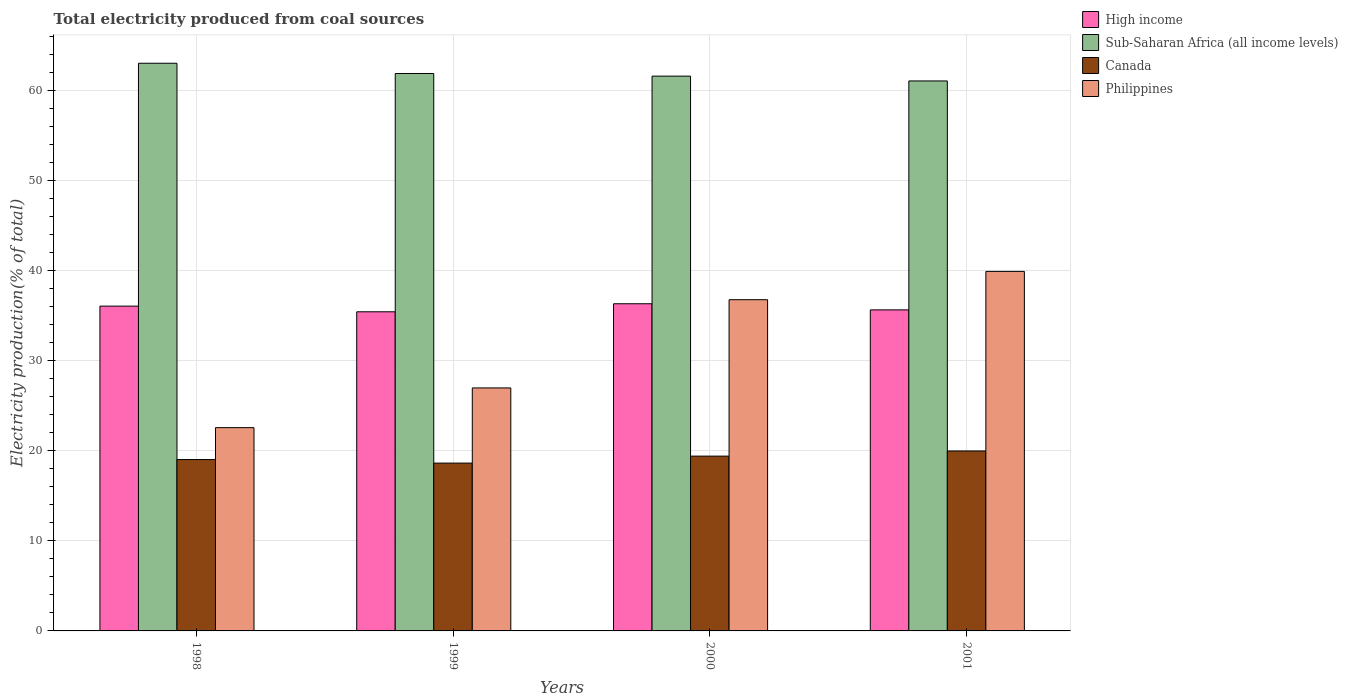How many different coloured bars are there?
Ensure brevity in your answer.  4. How many groups of bars are there?
Provide a short and direct response. 4. What is the total electricity produced in Canada in 2000?
Ensure brevity in your answer.  19.42. Across all years, what is the maximum total electricity produced in Canada?
Ensure brevity in your answer.  19.99. Across all years, what is the minimum total electricity produced in Sub-Saharan Africa (all income levels)?
Offer a very short reply. 61.09. In which year was the total electricity produced in Canada maximum?
Your response must be concise. 2001. What is the total total electricity produced in Sub-Saharan Africa (all income levels) in the graph?
Offer a very short reply. 247.68. What is the difference between the total electricity produced in High income in 2000 and that in 2001?
Make the answer very short. 0.68. What is the difference between the total electricity produced in Canada in 2000 and the total electricity produced in High income in 1999?
Ensure brevity in your answer.  -16.03. What is the average total electricity produced in Sub-Saharan Africa (all income levels) per year?
Give a very brief answer. 61.92. In the year 2000, what is the difference between the total electricity produced in High income and total electricity produced in Philippines?
Give a very brief answer. -0.45. In how many years, is the total electricity produced in Philippines greater than 46 %?
Make the answer very short. 0. What is the ratio of the total electricity produced in Philippines in 1998 to that in 2000?
Offer a terse response. 0.61. What is the difference between the highest and the second highest total electricity produced in Philippines?
Your answer should be very brief. 3.14. What is the difference between the highest and the lowest total electricity produced in High income?
Your response must be concise. 0.89. Is it the case that in every year, the sum of the total electricity produced in High income and total electricity produced in Philippines is greater than the sum of total electricity produced in Canada and total electricity produced in Sub-Saharan Africa (all income levels)?
Keep it short and to the point. Yes. What does the 1st bar from the left in 2000 represents?
Provide a succinct answer. High income. What does the 3rd bar from the right in 2000 represents?
Ensure brevity in your answer.  Sub-Saharan Africa (all income levels). Is it the case that in every year, the sum of the total electricity produced in Philippines and total electricity produced in Canada is greater than the total electricity produced in High income?
Ensure brevity in your answer.  Yes. How many bars are there?
Provide a short and direct response. 16. What is the difference between two consecutive major ticks on the Y-axis?
Offer a very short reply. 10. Does the graph contain any zero values?
Ensure brevity in your answer.  No. Where does the legend appear in the graph?
Your response must be concise. Top right. How many legend labels are there?
Provide a short and direct response. 4. What is the title of the graph?
Your response must be concise. Total electricity produced from coal sources. What is the label or title of the X-axis?
Your response must be concise. Years. What is the label or title of the Y-axis?
Keep it short and to the point. Electricity production(% of total). What is the Electricity production(% of total) in High income in 1998?
Offer a very short reply. 36.08. What is the Electricity production(% of total) of Sub-Saharan Africa (all income levels) in 1998?
Your answer should be very brief. 63.05. What is the Electricity production(% of total) in Canada in 1998?
Offer a very short reply. 19.03. What is the Electricity production(% of total) of Philippines in 1998?
Your answer should be very brief. 22.58. What is the Electricity production(% of total) of High income in 1999?
Provide a succinct answer. 35.45. What is the Electricity production(% of total) in Sub-Saharan Africa (all income levels) in 1999?
Make the answer very short. 61.91. What is the Electricity production(% of total) in Canada in 1999?
Keep it short and to the point. 18.64. What is the Electricity production(% of total) of Philippines in 1999?
Ensure brevity in your answer.  26.99. What is the Electricity production(% of total) of High income in 2000?
Make the answer very short. 36.34. What is the Electricity production(% of total) of Sub-Saharan Africa (all income levels) in 2000?
Your answer should be compact. 61.62. What is the Electricity production(% of total) in Canada in 2000?
Give a very brief answer. 19.42. What is the Electricity production(% of total) of Philippines in 2000?
Ensure brevity in your answer.  36.79. What is the Electricity production(% of total) in High income in 2001?
Your answer should be compact. 35.66. What is the Electricity production(% of total) in Sub-Saharan Africa (all income levels) in 2001?
Provide a succinct answer. 61.09. What is the Electricity production(% of total) in Canada in 2001?
Your answer should be very brief. 19.99. What is the Electricity production(% of total) in Philippines in 2001?
Keep it short and to the point. 39.93. Across all years, what is the maximum Electricity production(% of total) in High income?
Provide a short and direct response. 36.34. Across all years, what is the maximum Electricity production(% of total) in Sub-Saharan Africa (all income levels)?
Offer a terse response. 63.05. Across all years, what is the maximum Electricity production(% of total) of Canada?
Your answer should be compact. 19.99. Across all years, what is the maximum Electricity production(% of total) in Philippines?
Keep it short and to the point. 39.93. Across all years, what is the minimum Electricity production(% of total) of High income?
Offer a terse response. 35.45. Across all years, what is the minimum Electricity production(% of total) of Sub-Saharan Africa (all income levels)?
Provide a short and direct response. 61.09. Across all years, what is the minimum Electricity production(% of total) of Canada?
Give a very brief answer. 18.64. Across all years, what is the minimum Electricity production(% of total) of Philippines?
Your response must be concise. 22.58. What is the total Electricity production(% of total) in High income in the graph?
Make the answer very short. 143.52. What is the total Electricity production(% of total) in Sub-Saharan Africa (all income levels) in the graph?
Give a very brief answer. 247.68. What is the total Electricity production(% of total) in Canada in the graph?
Provide a succinct answer. 77.08. What is the total Electricity production(% of total) of Philippines in the graph?
Provide a short and direct response. 126.3. What is the difference between the Electricity production(% of total) in High income in 1998 and that in 1999?
Your response must be concise. 0.63. What is the difference between the Electricity production(% of total) of Sub-Saharan Africa (all income levels) in 1998 and that in 1999?
Give a very brief answer. 1.14. What is the difference between the Electricity production(% of total) in Canada in 1998 and that in 1999?
Offer a very short reply. 0.39. What is the difference between the Electricity production(% of total) in Philippines in 1998 and that in 1999?
Ensure brevity in your answer.  -4.41. What is the difference between the Electricity production(% of total) in High income in 1998 and that in 2000?
Provide a succinct answer. -0.26. What is the difference between the Electricity production(% of total) of Sub-Saharan Africa (all income levels) in 1998 and that in 2000?
Offer a terse response. 1.43. What is the difference between the Electricity production(% of total) in Canada in 1998 and that in 2000?
Your response must be concise. -0.38. What is the difference between the Electricity production(% of total) of Philippines in 1998 and that in 2000?
Your response must be concise. -14.21. What is the difference between the Electricity production(% of total) in High income in 1998 and that in 2001?
Provide a short and direct response. 0.42. What is the difference between the Electricity production(% of total) in Sub-Saharan Africa (all income levels) in 1998 and that in 2001?
Your answer should be very brief. 1.96. What is the difference between the Electricity production(% of total) in Canada in 1998 and that in 2001?
Offer a terse response. -0.95. What is the difference between the Electricity production(% of total) in Philippines in 1998 and that in 2001?
Your answer should be compact. -17.35. What is the difference between the Electricity production(% of total) in High income in 1999 and that in 2000?
Your answer should be compact. -0.89. What is the difference between the Electricity production(% of total) of Sub-Saharan Africa (all income levels) in 1999 and that in 2000?
Provide a succinct answer. 0.29. What is the difference between the Electricity production(% of total) of Canada in 1999 and that in 2000?
Your answer should be very brief. -0.78. What is the difference between the Electricity production(% of total) in Philippines in 1999 and that in 2000?
Ensure brevity in your answer.  -9.8. What is the difference between the Electricity production(% of total) in High income in 1999 and that in 2001?
Provide a short and direct response. -0.21. What is the difference between the Electricity production(% of total) of Sub-Saharan Africa (all income levels) in 1999 and that in 2001?
Ensure brevity in your answer.  0.82. What is the difference between the Electricity production(% of total) in Canada in 1999 and that in 2001?
Provide a short and direct response. -1.35. What is the difference between the Electricity production(% of total) of Philippines in 1999 and that in 2001?
Your response must be concise. -12.94. What is the difference between the Electricity production(% of total) in High income in 2000 and that in 2001?
Ensure brevity in your answer.  0.68. What is the difference between the Electricity production(% of total) of Sub-Saharan Africa (all income levels) in 2000 and that in 2001?
Your response must be concise. 0.53. What is the difference between the Electricity production(% of total) in Canada in 2000 and that in 2001?
Ensure brevity in your answer.  -0.57. What is the difference between the Electricity production(% of total) in Philippines in 2000 and that in 2001?
Provide a succinct answer. -3.14. What is the difference between the Electricity production(% of total) of High income in 1998 and the Electricity production(% of total) of Sub-Saharan Africa (all income levels) in 1999?
Your response must be concise. -25.84. What is the difference between the Electricity production(% of total) of High income in 1998 and the Electricity production(% of total) of Canada in 1999?
Provide a succinct answer. 17.44. What is the difference between the Electricity production(% of total) in High income in 1998 and the Electricity production(% of total) in Philippines in 1999?
Offer a very short reply. 9.09. What is the difference between the Electricity production(% of total) in Sub-Saharan Africa (all income levels) in 1998 and the Electricity production(% of total) in Canada in 1999?
Offer a terse response. 44.41. What is the difference between the Electricity production(% of total) of Sub-Saharan Africa (all income levels) in 1998 and the Electricity production(% of total) of Philippines in 1999?
Offer a terse response. 36.06. What is the difference between the Electricity production(% of total) of Canada in 1998 and the Electricity production(% of total) of Philippines in 1999?
Your answer should be compact. -7.96. What is the difference between the Electricity production(% of total) of High income in 1998 and the Electricity production(% of total) of Sub-Saharan Africa (all income levels) in 2000?
Your answer should be compact. -25.55. What is the difference between the Electricity production(% of total) in High income in 1998 and the Electricity production(% of total) in Canada in 2000?
Give a very brief answer. 16.66. What is the difference between the Electricity production(% of total) of High income in 1998 and the Electricity production(% of total) of Philippines in 2000?
Offer a very short reply. -0.71. What is the difference between the Electricity production(% of total) of Sub-Saharan Africa (all income levels) in 1998 and the Electricity production(% of total) of Canada in 2000?
Give a very brief answer. 43.64. What is the difference between the Electricity production(% of total) in Sub-Saharan Africa (all income levels) in 1998 and the Electricity production(% of total) in Philippines in 2000?
Give a very brief answer. 26.26. What is the difference between the Electricity production(% of total) in Canada in 1998 and the Electricity production(% of total) in Philippines in 2000?
Your answer should be compact. -17.76. What is the difference between the Electricity production(% of total) in High income in 1998 and the Electricity production(% of total) in Sub-Saharan Africa (all income levels) in 2001?
Keep it short and to the point. -25.01. What is the difference between the Electricity production(% of total) in High income in 1998 and the Electricity production(% of total) in Canada in 2001?
Make the answer very short. 16.09. What is the difference between the Electricity production(% of total) in High income in 1998 and the Electricity production(% of total) in Philippines in 2001?
Offer a very short reply. -3.86. What is the difference between the Electricity production(% of total) of Sub-Saharan Africa (all income levels) in 1998 and the Electricity production(% of total) of Canada in 2001?
Your answer should be compact. 43.06. What is the difference between the Electricity production(% of total) of Sub-Saharan Africa (all income levels) in 1998 and the Electricity production(% of total) of Philippines in 2001?
Your answer should be very brief. 23.12. What is the difference between the Electricity production(% of total) of Canada in 1998 and the Electricity production(% of total) of Philippines in 2001?
Keep it short and to the point. -20.9. What is the difference between the Electricity production(% of total) in High income in 1999 and the Electricity production(% of total) in Sub-Saharan Africa (all income levels) in 2000?
Make the answer very short. -26.18. What is the difference between the Electricity production(% of total) in High income in 1999 and the Electricity production(% of total) in Canada in 2000?
Make the answer very short. 16.03. What is the difference between the Electricity production(% of total) in High income in 1999 and the Electricity production(% of total) in Philippines in 2000?
Offer a terse response. -1.34. What is the difference between the Electricity production(% of total) of Sub-Saharan Africa (all income levels) in 1999 and the Electricity production(% of total) of Canada in 2000?
Make the answer very short. 42.5. What is the difference between the Electricity production(% of total) of Sub-Saharan Africa (all income levels) in 1999 and the Electricity production(% of total) of Philippines in 2000?
Give a very brief answer. 25.12. What is the difference between the Electricity production(% of total) in Canada in 1999 and the Electricity production(% of total) in Philippines in 2000?
Provide a succinct answer. -18.15. What is the difference between the Electricity production(% of total) in High income in 1999 and the Electricity production(% of total) in Sub-Saharan Africa (all income levels) in 2001?
Provide a short and direct response. -25.64. What is the difference between the Electricity production(% of total) in High income in 1999 and the Electricity production(% of total) in Canada in 2001?
Provide a short and direct response. 15.46. What is the difference between the Electricity production(% of total) of High income in 1999 and the Electricity production(% of total) of Philippines in 2001?
Make the answer very short. -4.49. What is the difference between the Electricity production(% of total) in Sub-Saharan Africa (all income levels) in 1999 and the Electricity production(% of total) in Canada in 2001?
Give a very brief answer. 41.92. What is the difference between the Electricity production(% of total) of Sub-Saharan Africa (all income levels) in 1999 and the Electricity production(% of total) of Philippines in 2001?
Your answer should be very brief. 21.98. What is the difference between the Electricity production(% of total) of Canada in 1999 and the Electricity production(% of total) of Philippines in 2001?
Your response must be concise. -21.29. What is the difference between the Electricity production(% of total) in High income in 2000 and the Electricity production(% of total) in Sub-Saharan Africa (all income levels) in 2001?
Make the answer very short. -24.75. What is the difference between the Electricity production(% of total) of High income in 2000 and the Electricity production(% of total) of Canada in 2001?
Your answer should be very brief. 16.35. What is the difference between the Electricity production(% of total) in High income in 2000 and the Electricity production(% of total) in Philippines in 2001?
Your response must be concise. -3.59. What is the difference between the Electricity production(% of total) of Sub-Saharan Africa (all income levels) in 2000 and the Electricity production(% of total) of Canada in 2001?
Your answer should be very brief. 41.63. What is the difference between the Electricity production(% of total) of Sub-Saharan Africa (all income levels) in 2000 and the Electricity production(% of total) of Philippines in 2001?
Keep it short and to the point. 21.69. What is the difference between the Electricity production(% of total) of Canada in 2000 and the Electricity production(% of total) of Philippines in 2001?
Your response must be concise. -20.52. What is the average Electricity production(% of total) in High income per year?
Offer a terse response. 35.88. What is the average Electricity production(% of total) of Sub-Saharan Africa (all income levels) per year?
Ensure brevity in your answer.  61.92. What is the average Electricity production(% of total) of Canada per year?
Make the answer very short. 19.27. What is the average Electricity production(% of total) in Philippines per year?
Make the answer very short. 31.57. In the year 1998, what is the difference between the Electricity production(% of total) of High income and Electricity production(% of total) of Sub-Saharan Africa (all income levels)?
Offer a terse response. -26.98. In the year 1998, what is the difference between the Electricity production(% of total) of High income and Electricity production(% of total) of Canada?
Provide a short and direct response. 17.04. In the year 1998, what is the difference between the Electricity production(% of total) in High income and Electricity production(% of total) in Philippines?
Your answer should be very brief. 13.5. In the year 1998, what is the difference between the Electricity production(% of total) in Sub-Saharan Africa (all income levels) and Electricity production(% of total) in Canada?
Your response must be concise. 44.02. In the year 1998, what is the difference between the Electricity production(% of total) in Sub-Saharan Africa (all income levels) and Electricity production(% of total) in Philippines?
Your answer should be very brief. 40.47. In the year 1998, what is the difference between the Electricity production(% of total) of Canada and Electricity production(% of total) of Philippines?
Provide a short and direct response. -3.54. In the year 1999, what is the difference between the Electricity production(% of total) in High income and Electricity production(% of total) in Sub-Saharan Africa (all income levels)?
Offer a terse response. -26.47. In the year 1999, what is the difference between the Electricity production(% of total) in High income and Electricity production(% of total) in Canada?
Ensure brevity in your answer.  16.81. In the year 1999, what is the difference between the Electricity production(% of total) in High income and Electricity production(% of total) in Philippines?
Provide a short and direct response. 8.46. In the year 1999, what is the difference between the Electricity production(% of total) of Sub-Saharan Africa (all income levels) and Electricity production(% of total) of Canada?
Your answer should be very brief. 43.27. In the year 1999, what is the difference between the Electricity production(% of total) in Sub-Saharan Africa (all income levels) and Electricity production(% of total) in Philippines?
Offer a very short reply. 34.92. In the year 1999, what is the difference between the Electricity production(% of total) of Canada and Electricity production(% of total) of Philippines?
Provide a succinct answer. -8.35. In the year 2000, what is the difference between the Electricity production(% of total) in High income and Electricity production(% of total) in Sub-Saharan Africa (all income levels)?
Keep it short and to the point. -25.28. In the year 2000, what is the difference between the Electricity production(% of total) of High income and Electricity production(% of total) of Canada?
Keep it short and to the point. 16.92. In the year 2000, what is the difference between the Electricity production(% of total) in High income and Electricity production(% of total) in Philippines?
Make the answer very short. -0.45. In the year 2000, what is the difference between the Electricity production(% of total) of Sub-Saharan Africa (all income levels) and Electricity production(% of total) of Canada?
Offer a terse response. 42.21. In the year 2000, what is the difference between the Electricity production(% of total) of Sub-Saharan Africa (all income levels) and Electricity production(% of total) of Philippines?
Ensure brevity in your answer.  24.83. In the year 2000, what is the difference between the Electricity production(% of total) of Canada and Electricity production(% of total) of Philippines?
Your answer should be very brief. -17.37. In the year 2001, what is the difference between the Electricity production(% of total) in High income and Electricity production(% of total) in Sub-Saharan Africa (all income levels)?
Give a very brief answer. -25.43. In the year 2001, what is the difference between the Electricity production(% of total) of High income and Electricity production(% of total) of Canada?
Your response must be concise. 15.67. In the year 2001, what is the difference between the Electricity production(% of total) of High income and Electricity production(% of total) of Philippines?
Provide a short and direct response. -4.28. In the year 2001, what is the difference between the Electricity production(% of total) of Sub-Saharan Africa (all income levels) and Electricity production(% of total) of Canada?
Provide a short and direct response. 41.1. In the year 2001, what is the difference between the Electricity production(% of total) of Sub-Saharan Africa (all income levels) and Electricity production(% of total) of Philippines?
Your answer should be very brief. 21.15. In the year 2001, what is the difference between the Electricity production(% of total) of Canada and Electricity production(% of total) of Philippines?
Provide a succinct answer. -19.95. What is the ratio of the Electricity production(% of total) of High income in 1998 to that in 1999?
Provide a short and direct response. 1.02. What is the ratio of the Electricity production(% of total) in Sub-Saharan Africa (all income levels) in 1998 to that in 1999?
Make the answer very short. 1.02. What is the ratio of the Electricity production(% of total) in Canada in 1998 to that in 1999?
Make the answer very short. 1.02. What is the ratio of the Electricity production(% of total) in Philippines in 1998 to that in 1999?
Offer a very short reply. 0.84. What is the ratio of the Electricity production(% of total) in Sub-Saharan Africa (all income levels) in 1998 to that in 2000?
Provide a succinct answer. 1.02. What is the ratio of the Electricity production(% of total) of Canada in 1998 to that in 2000?
Give a very brief answer. 0.98. What is the ratio of the Electricity production(% of total) in Philippines in 1998 to that in 2000?
Make the answer very short. 0.61. What is the ratio of the Electricity production(% of total) of High income in 1998 to that in 2001?
Your answer should be compact. 1.01. What is the ratio of the Electricity production(% of total) of Sub-Saharan Africa (all income levels) in 1998 to that in 2001?
Provide a short and direct response. 1.03. What is the ratio of the Electricity production(% of total) in Canada in 1998 to that in 2001?
Provide a short and direct response. 0.95. What is the ratio of the Electricity production(% of total) in Philippines in 1998 to that in 2001?
Provide a succinct answer. 0.57. What is the ratio of the Electricity production(% of total) of High income in 1999 to that in 2000?
Make the answer very short. 0.98. What is the ratio of the Electricity production(% of total) in Philippines in 1999 to that in 2000?
Provide a succinct answer. 0.73. What is the ratio of the Electricity production(% of total) of Sub-Saharan Africa (all income levels) in 1999 to that in 2001?
Offer a very short reply. 1.01. What is the ratio of the Electricity production(% of total) of Canada in 1999 to that in 2001?
Your answer should be very brief. 0.93. What is the ratio of the Electricity production(% of total) in Philippines in 1999 to that in 2001?
Your answer should be compact. 0.68. What is the ratio of the Electricity production(% of total) in High income in 2000 to that in 2001?
Keep it short and to the point. 1.02. What is the ratio of the Electricity production(% of total) of Sub-Saharan Africa (all income levels) in 2000 to that in 2001?
Provide a short and direct response. 1.01. What is the ratio of the Electricity production(% of total) in Canada in 2000 to that in 2001?
Offer a very short reply. 0.97. What is the ratio of the Electricity production(% of total) in Philippines in 2000 to that in 2001?
Your answer should be very brief. 0.92. What is the difference between the highest and the second highest Electricity production(% of total) in High income?
Make the answer very short. 0.26. What is the difference between the highest and the second highest Electricity production(% of total) in Sub-Saharan Africa (all income levels)?
Your response must be concise. 1.14. What is the difference between the highest and the second highest Electricity production(% of total) in Canada?
Offer a terse response. 0.57. What is the difference between the highest and the second highest Electricity production(% of total) in Philippines?
Your response must be concise. 3.14. What is the difference between the highest and the lowest Electricity production(% of total) in High income?
Keep it short and to the point. 0.89. What is the difference between the highest and the lowest Electricity production(% of total) in Sub-Saharan Africa (all income levels)?
Offer a very short reply. 1.96. What is the difference between the highest and the lowest Electricity production(% of total) in Canada?
Make the answer very short. 1.35. What is the difference between the highest and the lowest Electricity production(% of total) in Philippines?
Your answer should be very brief. 17.35. 